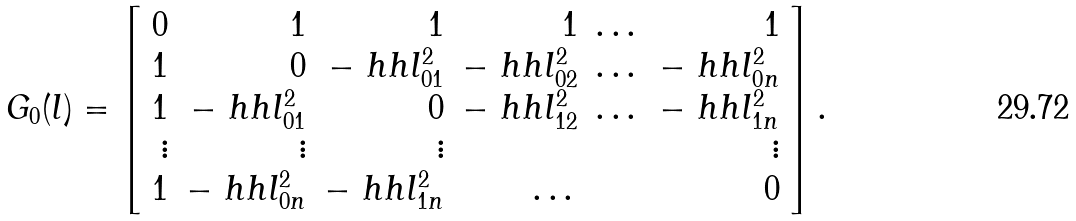Convert formula to latex. <formula><loc_0><loc_0><loc_500><loc_500>G _ { 0 } ( l ) = \left [ \begin{array} { r r r r r r r } 0 & 1 & 1 & 1 & \dots & 1 \\ 1 & 0 & - \ h h l _ { 0 1 } ^ { 2 } & - \ h h l _ { 0 2 } ^ { 2 } & \dots & - \ h h l _ { 0 n } ^ { 2 } \\ 1 & - \ h h l _ { 0 1 } ^ { 2 } & 0 & - \ h h l _ { 1 2 } ^ { 2 } & \dots & - \ h h l _ { 1 n } ^ { 2 } \\ \vdots & \vdots & \vdots & & & \vdots \\ 1 & - \ h h l _ { 0 n } ^ { 2 } & - \ h h l _ { 1 n } ^ { 2 } & \dots & & 0 \end{array} \right ] .</formula> 